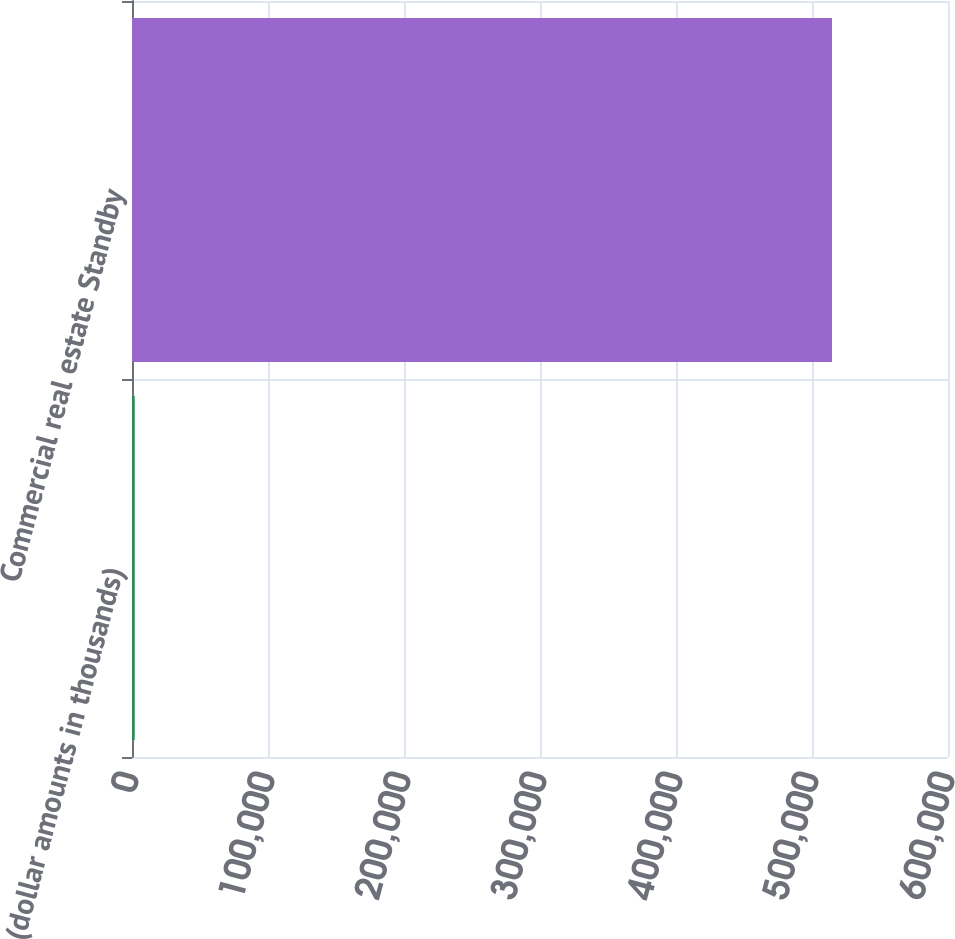<chart> <loc_0><loc_0><loc_500><loc_500><bar_chart><fcel>(dollar amounts in thousands)<fcel>Commercial real estate Standby<nl><fcel>2012<fcel>514705<nl></chart> 